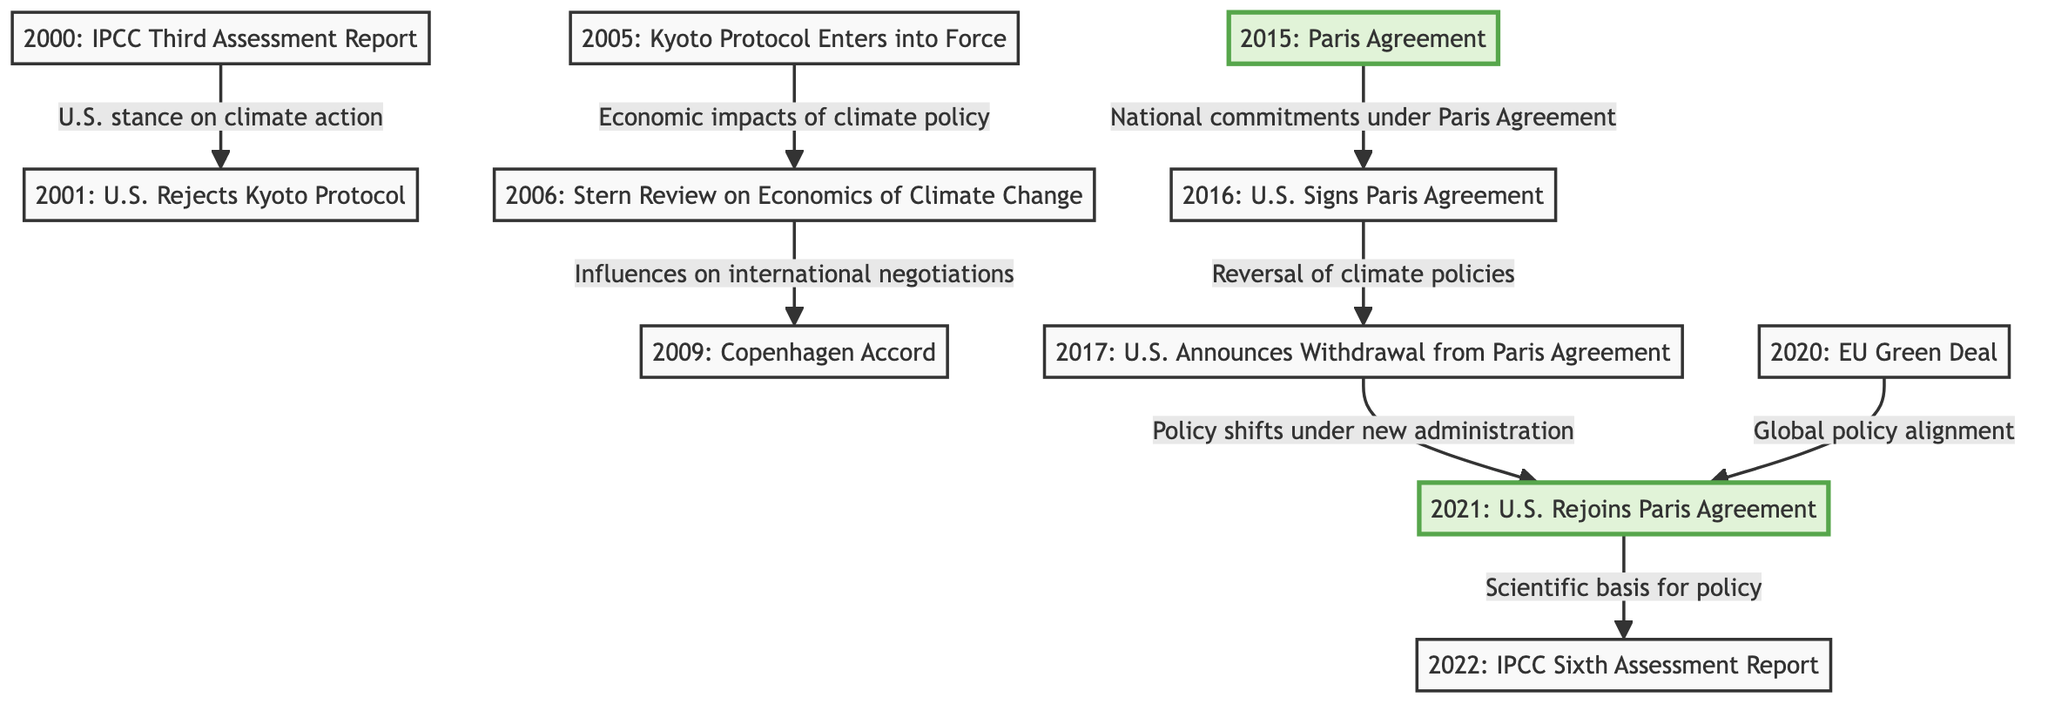What significant event occurred in 2005? The diagram shows that in 2005, the Kyoto Protocol entered into force, which is highlighted next to that specific node.
Answer: Kyoto Protocol Enters into Force Which event directly influenced the Copenhagen Accord? The diagram indicates that the Stern Review on the Economics of Climate Change influences the international negotiations in 2009, leading to the Copenhagen Accord.
Answer: Stern Review on Economics of Climate Change How many key events are highlighted in the diagram? Upon reviewing the diagram, there are two highlighted nodes, which are the Paris Agreement in 2015 and the U.S. Rejoining the Paris Agreement in 2021.
Answer: 2 What policy shift occurred after the U.S. announced withdrawal from the Paris Agreement in 2017? The diagram indicates a policy shift under a new administration in 2021 after the U.S. announced its withdrawal from the agreement in 2017.
Answer: Policy shifts under new administration Which two events are connected by a direct influence in 2021? The diagram shows that the U.S. rejoins the Paris Agreement in 2021 is directly influenced by the EU Green Deal in 2020.
Answer: U.S. Rejoins Paris Agreement and EU Green Deal What major international agreement was signed in 2016? The significant event in 2016 per the diagram is the signing of the Paris Agreement by the U.S., which is specifically noted.
Answer: Paris Agreement What was the influence mentioned for the relationship between the IPCC Sixth Assessment Report and national commitments? The diagram denotes that the scientific basis for policy is supported by the IPCC Sixth Assessment Report, which follows the commitments under the Paris Agreement.
Answer: Scientific basis for policy Which event led to the U.S. rejecting the Kyoto Protocol in 2001? The diagram illustrates a relationship where the U.S. stance on climate action leads to the rejection of the Kyoto Protocol in 2001.
Answer: U.S. stance on climate action 